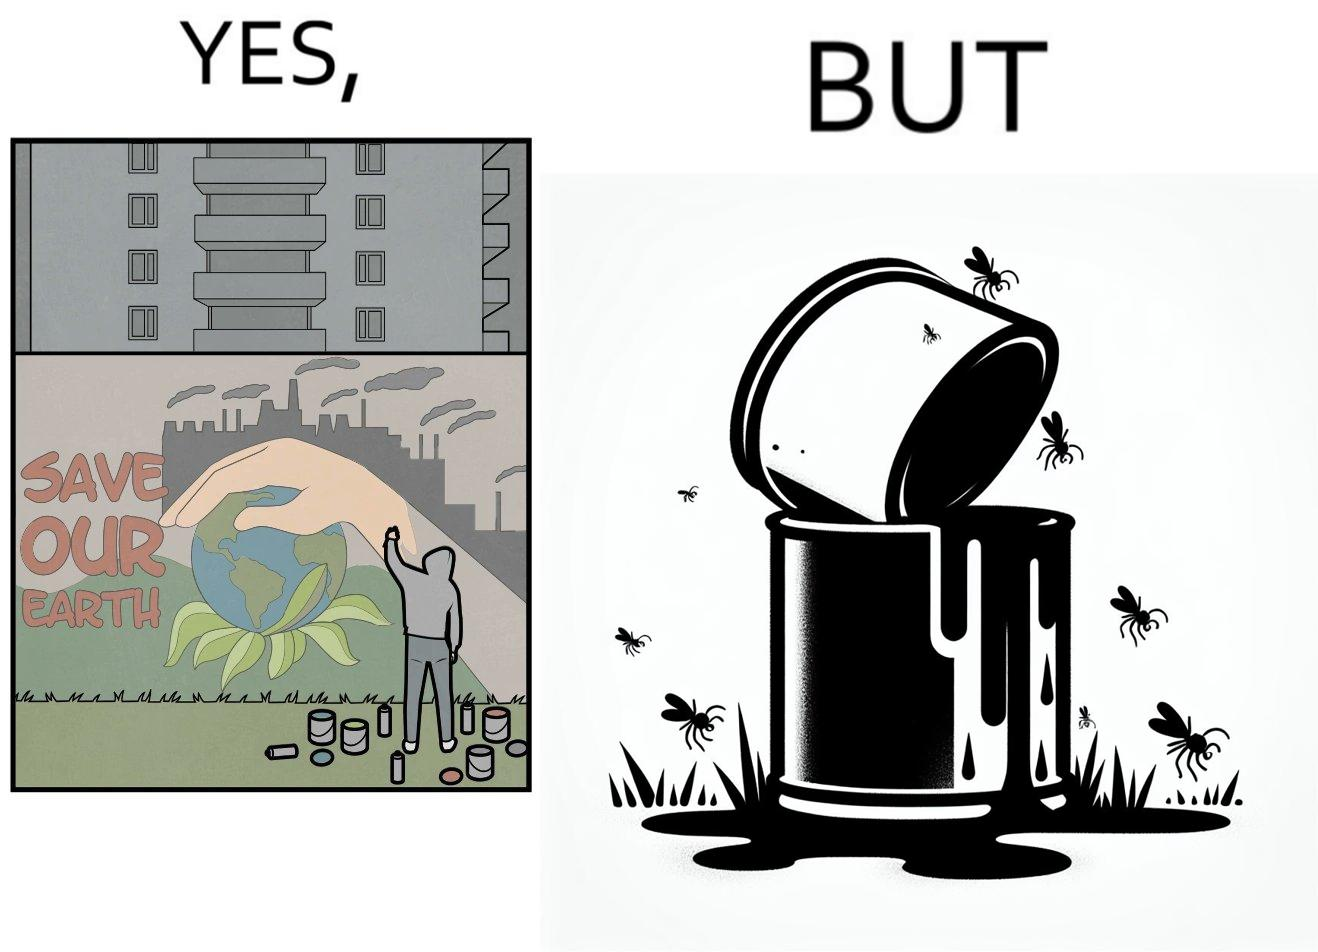Describe what you see in this image. The image is ironical, as the cans of paint used to make graffiti on the theme "Save the Earth" seems to be destroying the Earth when it overflows on the grass, as it is harmful for the flora and fauna, as can be seen from the dying insects. 